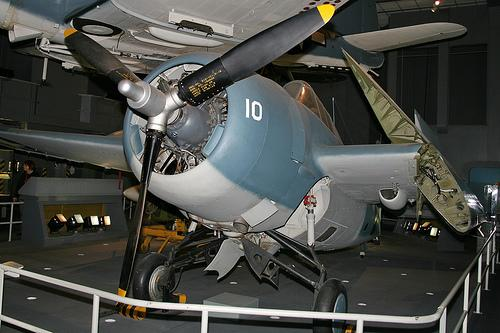Give a brief description of the aircraft's propeller and the number displayed on its side. The aircraft has a large, black and yellow propeller, with the number 10 displayed in white on its side. Mention the color and condition of the airplane on display. The airplane is blue and white and seems to be old as it has its right wing broken. Mention a notable detail about the lighting setup in the image. There is a panel of four lights on the floor, illuminating the airplane display. Provide a brief overview of the main elements found in the image.  An old blue and white airplane is on display, with a broken right wing, large propellers, and number 10 printed on the side, surrounded by a fence and illuminated by floor lights. Describe something unique or unexpected about the airplane on display. The right wing of the airplane is broken, revealing the inner structure and wires. Describe how the airplane is being supported and the area around it. A metal frame supports the plane's wheels, while the area around the plane is fenced, and a rail surrounds it. Write a short sentence describing the airplane's propellers and their colors. The airplane's propellers are black with yellow tips and are quite large in size. Mention a detail about the plane's appearance and the position of the person in the image. The plane has the number 10 printed in white on its side, and there is a person standing in the aisle of the museum. Point out the most prominent feature of the airplane in the image and its state. The airplane has a broken right wing with wires exposed, and it is held up by a metal frame supporting its wheels. Describe the condition of the floor in the image. The floor appears to be shiny and potentially slippery, reflecting the lights above. Observe the wooden fence that completely encircles the aircraft. The captions mention a metallic fence and a rail surrounding the display, so mentioning a wooden fence could mislead the viewer. The propeller is entirely made of silver metal. The captions state that the propeller is black with a yellow tip, so mentioning it as entirely made of silver metal could mislead the viewer. The airplane is being supported by a wooden structure instead of a metal frame. The original captions mention a metal frame supporting the plane's wheels. Introducing a wooden structure could mislead the viewer. Notice the outdoor setting of the broken plane in a field. The captions mention that the broken plane is indoors, in a museum aisle. So, by mentioning an outdoor setting in a field, we mislead the viewer. There is a neatly intact left wing with no signs of damage. The captions mention that the right wing of the plane is broken with wires exposed, implying damage. Mentioning a neatly intact left wing contradicts this information. Is the number 32 printed in red on the side of the plane? The original captions mention the number 10 in white letters on the plane, so mentioning the number 32 in red could confuse the viewer. Identify the small pink and purple lights in the corner of the room. The captions mention four lights illuminating the airplane display but don't mention them being pink and purple, so adding these colors could mislead the viewer. Can you spot the large blue and yellow umbrella next to the plane? There are no mentions of an umbrella in the captions, so introducing an unrelated object could confuse the viewer. Is the plane on display green with red stripes? The original captions mention that the aircraft is blue in color, so mentioning it as green with red stripes could mislead the viewer. Can you see five white plastic wheels beneath the airplane? The captions mention two black wheels, so mentioning five white plastic wheels could confuse the viewer. 